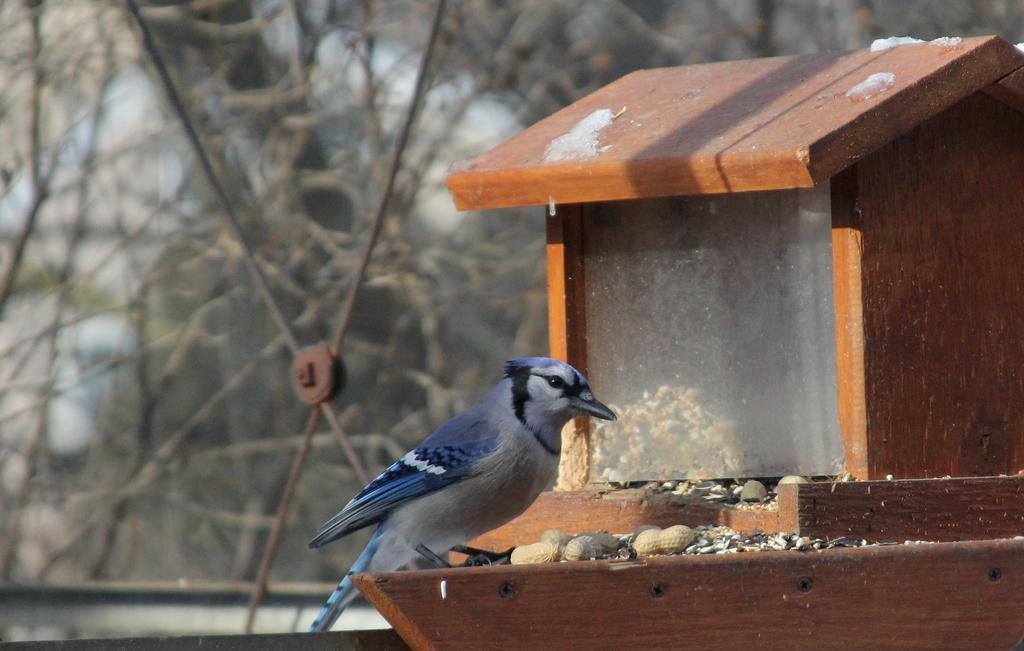Please provide a concise description of this image. This picture shows a bird house and we see a bird and some groundnuts and food and we see trees. The color of the bird is blue and black. 